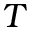<formula> <loc_0><loc_0><loc_500><loc_500>T</formula> 